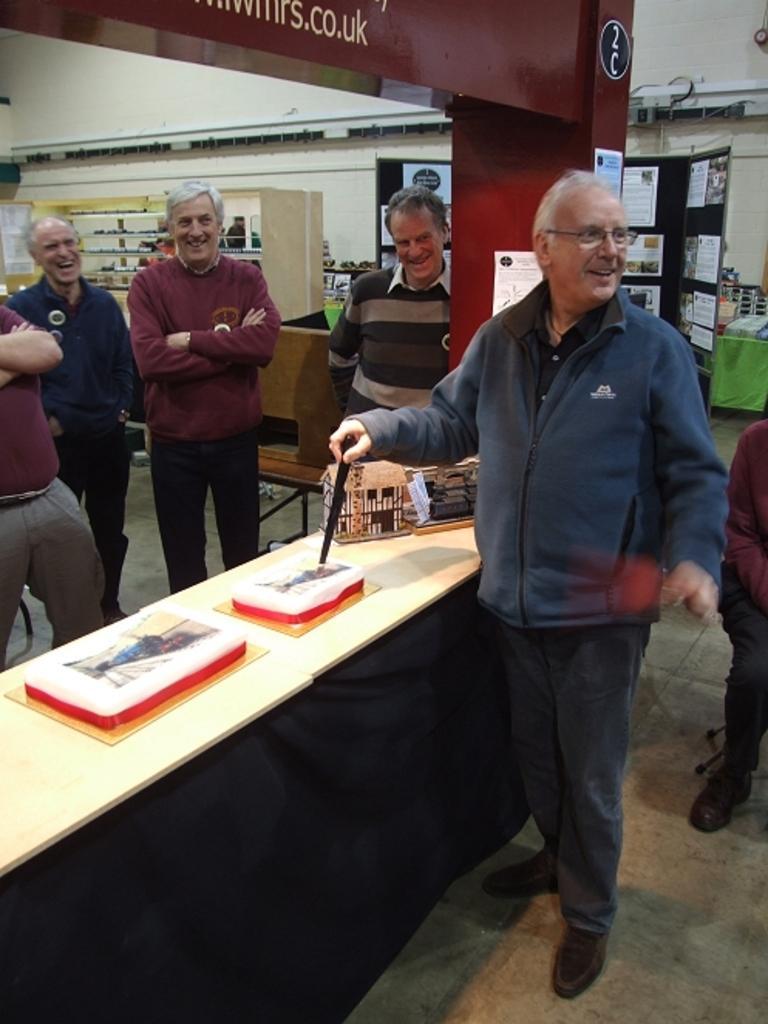How would you summarize this image in a sentence or two? As we can see in the image there is a wall, banner, papers on board, few people standing over here and there is a table. On table there are books and a box. 